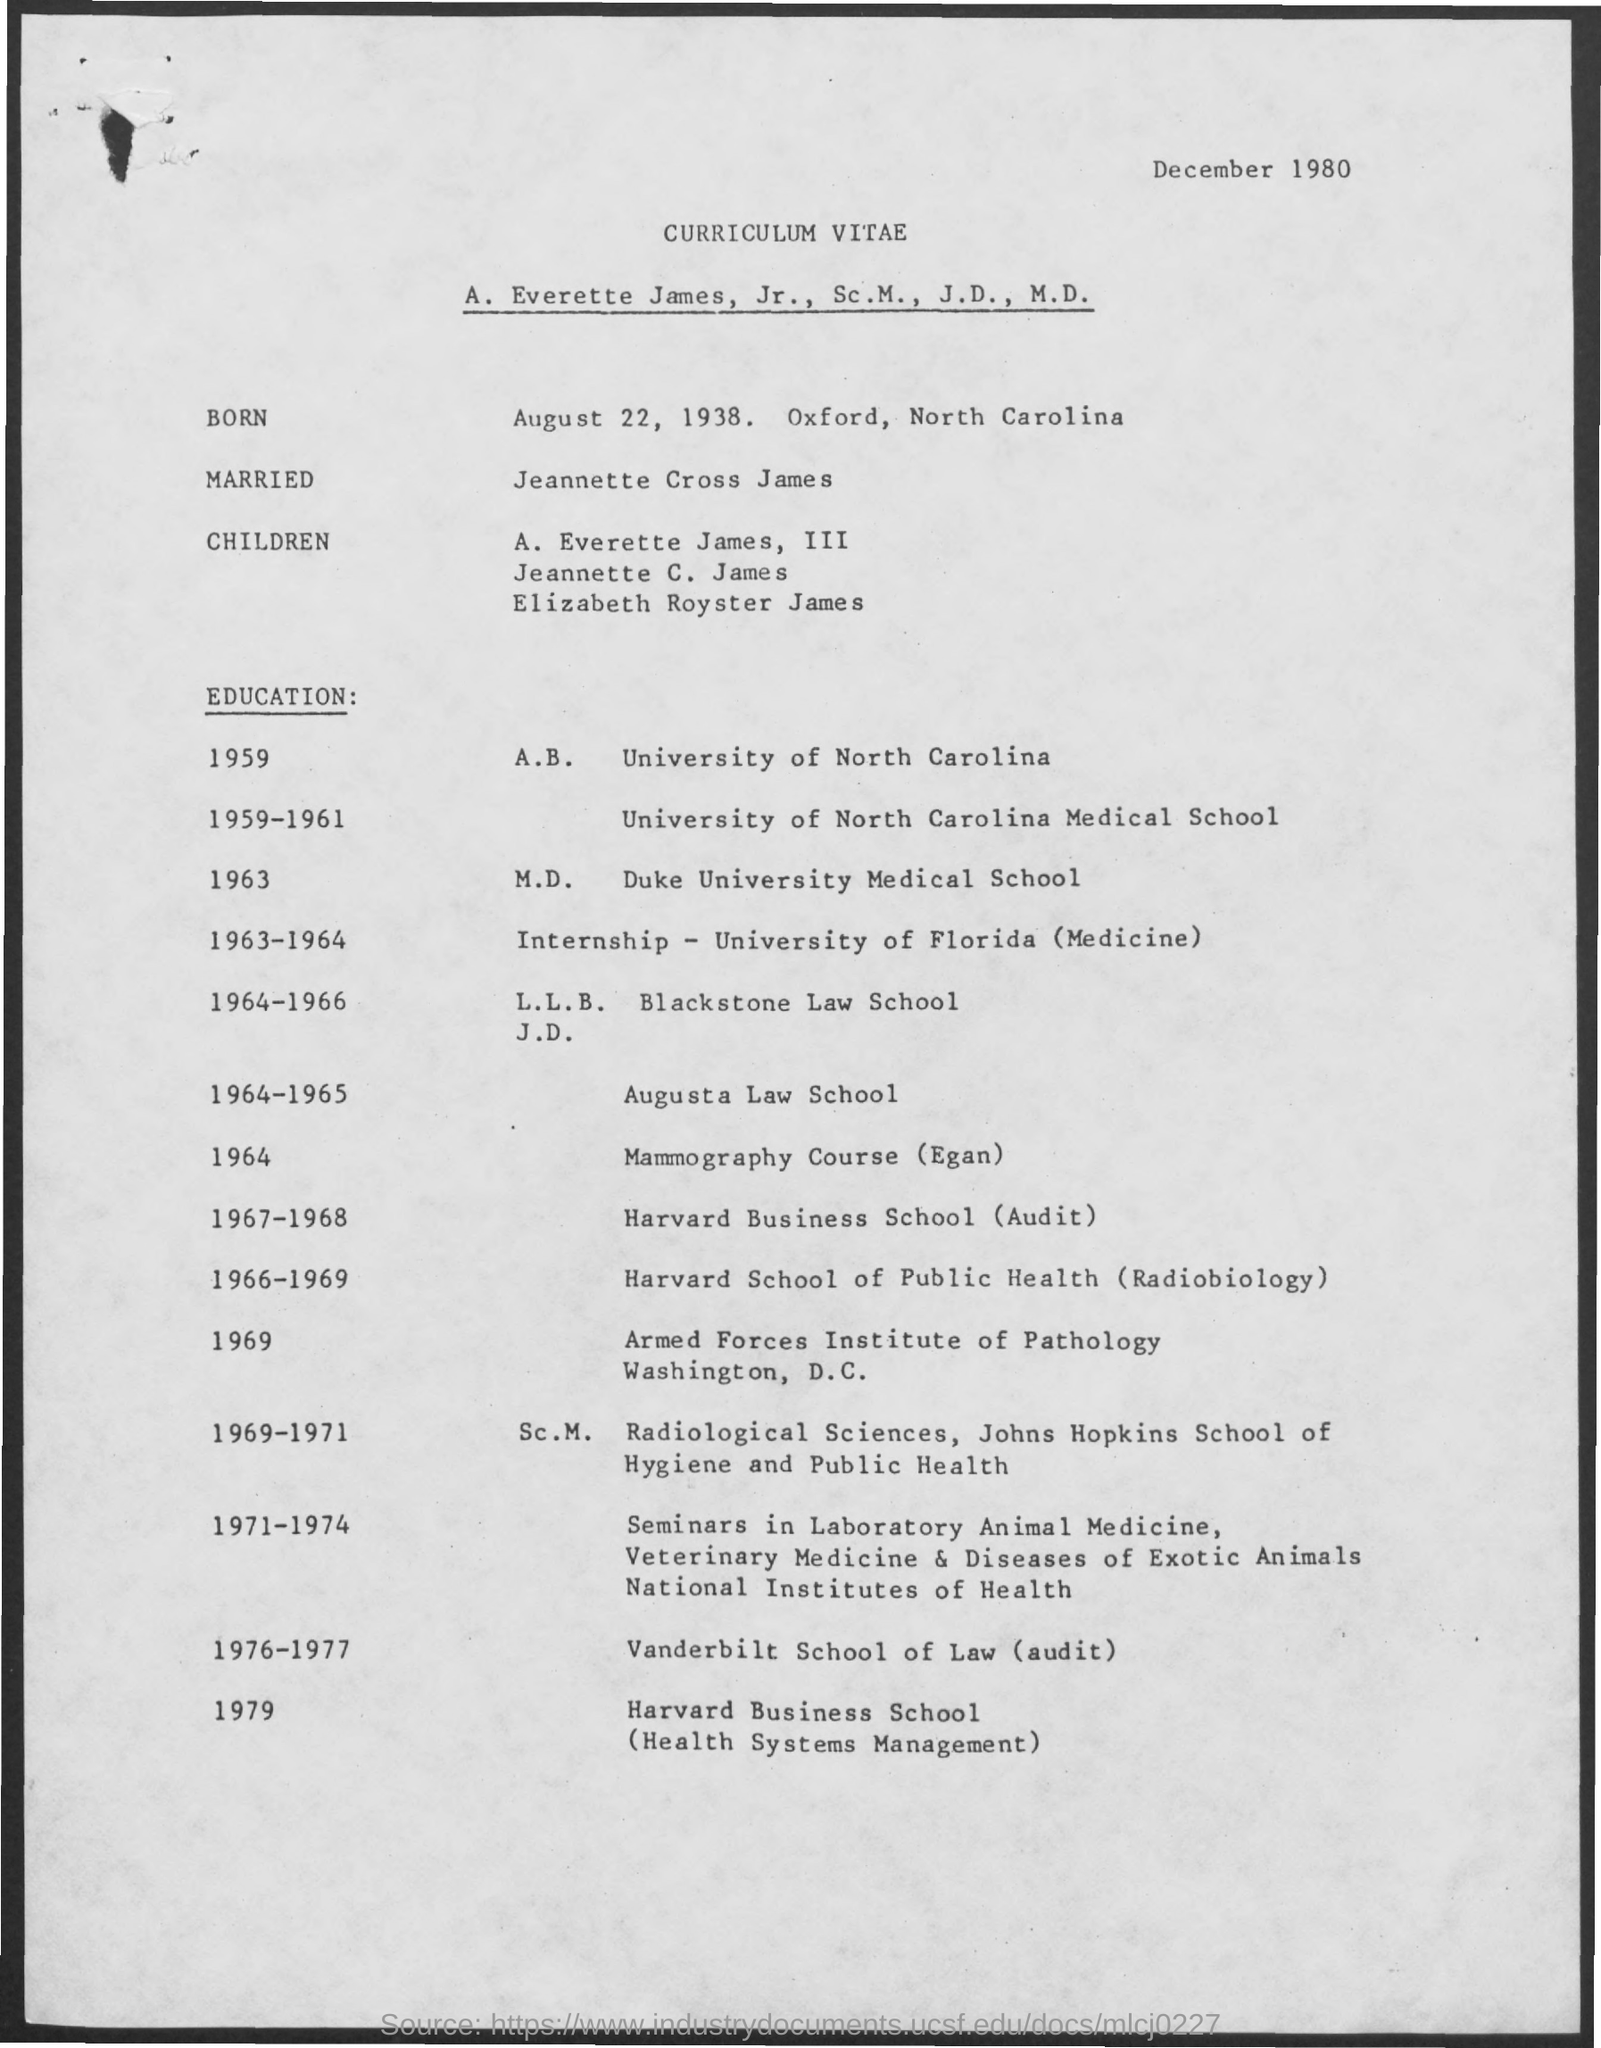What is the date on the document?
Provide a succinct answer. December 1980. When was he Born?
Offer a very short reply. August 22, 1938. When was he at Augusta Law School?
Your answer should be compact. 1964-1965. When was he at Vanderbilt School of Law(audit)?
Provide a short and direct response. 1976-1977. 